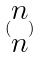<formula> <loc_0><loc_0><loc_500><loc_500>( \begin{matrix} n \\ n \end{matrix} )</formula> 